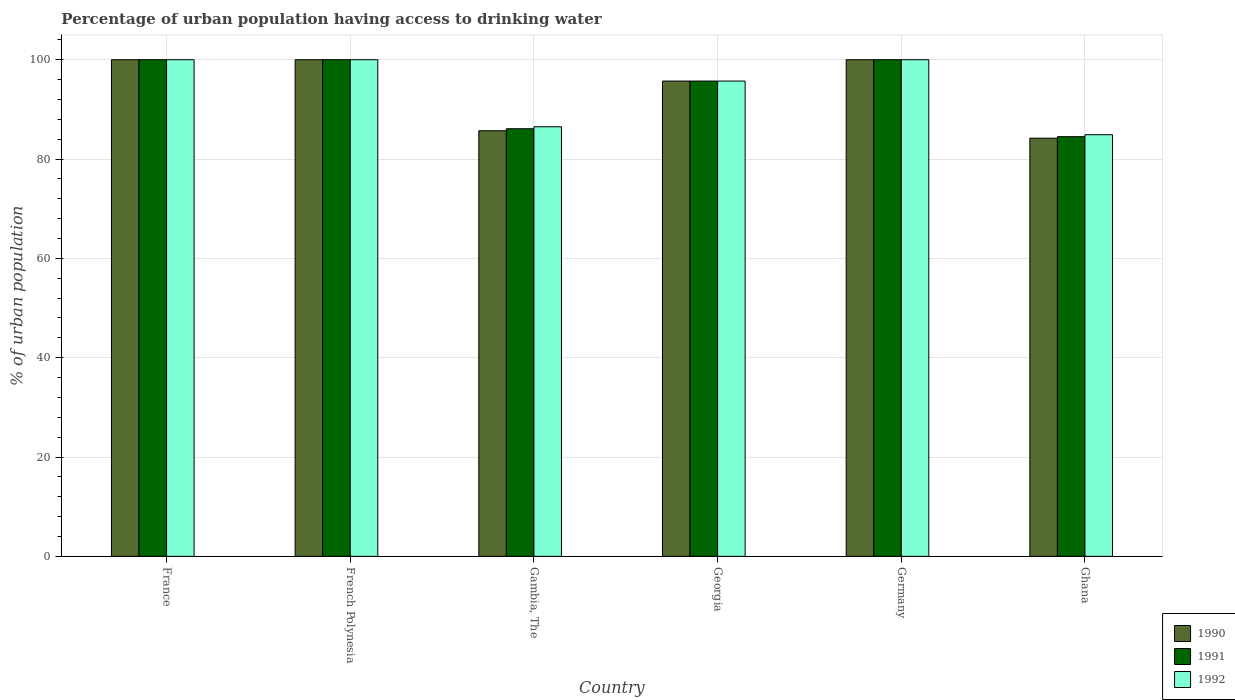How many different coloured bars are there?
Your answer should be compact. 3. How many groups of bars are there?
Give a very brief answer. 6. How many bars are there on the 5th tick from the right?
Offer a terse response. 3. What is the label of the 4th group of bars from the left?
Give a very brief answer. Georgia. What is the percentage of urban population having access to drinking water in 1991 in Ghana?
Offer a terse response. 84.5. Across all countries, what is the minimum percentage of urban population having access to drinking water in 1990?
Give a very brief answer. 84.2. In which country was the percentage of urban population having access to drinking water in 1990 maximum?
Provide a short and direct response. France. In which country was the percentage of urban population having access to drinking water in 1992 minimum?
Offer a very short reply. Ghana. What is the total percentage of urban population having access to drinking water in 1990 in the graph?
Give a very brief answer. 565.6. What is the difference between the percentage of urban population having access to drinking water in 1991 in France and that in Gambia, The?
Ensure brevity in your answer.  13.9. What is the difference between the percentage of urban population having access to drinking water in 1990 in Germany and the percentage of urban population having access to drinking water in 1992 in France?
Make the answer very short. 0. What is the average percentage of urban population having access to drinking water in 1991 per country?
Your answer should be compact. 94.38. What is the difference between the percentage of urban population having access to drinking water of/in 1990 and percentage of urban population having access to drinking water of/in 1992 in France?
Your response must be concise. 0. In how many countries, is the percentage of urban population having access to drinking water in 1991 greater than 68 %?
Your answer should be compact. 6. What is the ratio of the percentage of urban population having access to drinking water in 1991 in Georgia to that in Ghana?
Offer a terse response. 1.13. Is the difference between the percentage of urban population having access to drinking water in 1990 in France and French Polynesia greater than the difference between the percentage of urban population having access to drinking water in 1992 in France and French Polynesia?
Your response must be concise. No. What is the difference between the highest and the lowest percentage of urban population having access to drinking water in 1990?
Provide a short and direct response. 15.8. Is the sum of the percentage of urban population having access to drinking water in 1991 in France and Germany greater than the maximum percentage of urban population having access to drinking water in 1990 across all countries?
Provide a succinct answer. Yes. What does the 3rd bar from the right in Germany represents?
Offer a terse response. 1990. Is it the case that in every country, the sum of the percentage of urban population having access to drinking water in 1992 and percentage of urban population having access to drinking water in 1990 is greater than the percentage of urban population having access to drinking water in 1991?
Give a very brief answer. Yes. How many bars are there?
Provide a short and direct response. 18. Are all the bars in the graph horizontal?
Offer a very short reply. No. How many countries are there in the graph?
Offer a very short reply. 6. Are the values on the major ticks of Y-axis written in scientific E-notation?
Offer a terse response. No. How many legend labels are there?
Keep it short and to the point. 3. How are the legend labels stacked?
Offer a terse response. Vertical. What is the title of the graph?
Offer a terse response. Percentage of urban population having access to drinking water. Does "2002" appear as one of the legend labels in the graph?
Provide a short and direct response. No. What is the label or title of the Y-axis?
Give a very brief answer. % of urban population. What is the % of urban population of 1990 in France?
Provide a succinct answer. 100. What is the % of urban population of 1992 in France?
Offer a terse response. 100. What is the % of urban population in 1990 in Gambia, The?
Provide a short and direct response. 85.7. What is the % of urban population in 1991 in Gambia, The?
Offer a very short reply. 86.1. What is the % of urban population in 1992 in Gambia, The?
Give a very brief answer. 86.5. What is the % of urban population of 1990 in Georgia?
Your response must be concise. 95.7. What is the % of urban population in 1991 in Georgia?
Keep it short and to the point. 95.7. What is the % of urban population of 1992 in Georgia?
Make the answer very short. 95.7. What is the % of urban population in 1991 in Germany?
Ensure brevity in your answer.  100. What is the % of urban population in 1990 in Ghana?
Your response must be concise. 84.2. What is the % of urban population of 1991 in Ghana?
Provide a short and direct response. 84.5. What is the % of urban population of 1992 in Ghana?
Offer a terse response. 84.9. Across all countries, what is the maximum % of urban population in 1990?
Provide a succinct answer. 100. Across all countries, what is the minimum % of urban population of 1990?
Your response must be concise. 84.2. Across all countries, what is the minimum % of urban population in 1991?
Make the answer very short. 84.5. Across all countries, what is the minimum % of urban population of 1992?
Your answer should be compact. 84.9. What is the total % of urban population in 1990 in the graph?
Make the answer very short. 565.6. What is the total % of urban population of 1991 in the graph?
Give a very brief answer. 566.3. What is the total % of urban population of 1992 in the graph?
Make the answer very short. 567.1. What is the difference between the % of urban population in 1991 in France and that in French Polynesia?
Ensure brevity in your answer.  0. What is the difference between the % of urban population in 1992 in France and that in French Polynesia?
Ensure brevity in your answer.  0. What is the difference between the % of urban population of 1990 in France and that in Gambia, The?
Offer a very short reply. 14.3. What is the difference between the % of urban population in 1991 in France and that in Gambia, The?
Offer a very short reply. 13.9. What is the difference between the % of urban population in 1991 in France and that in Georgia?
Your answer should be compact. 4.3. What is the difference between the % of urban population in 1990 in France and that in Ghana?
Your response must be concise. 15.8. What is the difference between the % of urban population of 1991 in France and that in Ghana?
Make the answer very short. 15.5. What is the difference between the % of urban population in 1992 in France and that in Ghana?
Ensure brevity in your answer.  15.1. What is the difference between the % of urban population of 1990 in French Polynesia and that in Gambia, The?
Your answer should be compact. 14.3. What is the difference between the % of urban population in 1992 in French Polynesia and that in Georgia?
Give a very brief answer. 4.3. What is the difference between the % of urban population of 1990 in French Polynesia and that in Germany?
Your answer should be compact. 0. What is the difference between the % of urban population in 1991 in French Polynesia and that in Germany?
Your answer should be compact. 0. What is the difference between the % of urban population of 1992 in French Polynesia and that in Germany?
Your response must be concise. 0. What is the difference between the % of urban population in 1991 in French Polynesia and that in Ghana?
Offer a terse response. 15.5. What is the difference between the % of urban population of 1990 in Gambia, The and that in Georgia?
Make the answer very short. -10. What is the difference between the % of urban population in 1990 in Gambia, The and that in Germany?
Offer a terse response. -14.3. What is the difference between the % of urban population of 1992 in Gambia, The and that in Germany?
Make the answer very short. -13.5. What is the difference between the % of urban population in 1991 in Gambia, The and that in Ghana?
Ensure brevity in your answer.  1.6. What is the difference between the % of urban population of 1992 in Gambia, The and that in Ghana?
Your answer should be compact. 1.6. What is the difference between the % of urban population in 1991 in Georgia and that in Germany?
Offer a very short reply. -4.3. What is the difference between the % of urban population in 1990 in Georgia and that in Ghana?
Your answer should be very brief. 11.5. What is the difference between the % of urban population of 1990 in Germany and that in Ghana?
Provide a succinct answer. 15.8. What is the difference between the % of urban population of 1990 in France and the % of urban population of 1992 in French Polynesia?
Ensure brevity in your answer.  0. What is the difference between the % of urban population of 1991 in France and the % of urban population of 1992 in French Polynesia?
Offer a very short reply. 0. What is the difference between the % of urban population of 1990 in France and the % of urban population of 1991 in Gambia, The?
Offer a very short reply. 13.9. What is the difference between the % of urban population of 1990 in France and the % of urban population of 1992 in Gambia, The?
Your answer should be very brief. 13.5. What is the difference between the % of urban population of 1991 in France and the % of urban population of 1992 in Gambia, The?
Provide a short and direct response. 13.5. What is the difference between the % of urban population in 1990 in France and the % of urban population in 1992 in Georgia?
Make the answer very short. 4.3. What is the difference between the % of urban population in 1991 in France and the % of urban population in 1992 in Georgia?
Provide a succinct answer. 4.3. What is the difference between the % of urban population of 1990 in France and the % of urban population of 1992 in Ghana?
Provide a succinct answer. 15.1. What is the difference between the % of urban population of 1990 in French Polynesia and the % of urban population of 1991 in Gambia, The?
Make the answer very short. 13.9. What is the difference between the % of urban population of 1990 in French Polynesia and the % of urban population of 1992 in Georgia?
Ensure brevity in your answer.  4.3. What is the difference between the % of urban population in 1990 in French Polynesia and the % of urban population in 1991 in Germany?
Offer a very short reply. 0. What is the difference between the % of urban population of 1991 in French Polynesia and the % of urban population of 1992 in Germany?
Provide a short and direct response. 0. What is the difference between the % of urban population of 1990 in French Polynesia and the % of urban population of 1991 in Ghana?
Keep it short and to the point. 15.5. What is the difference between the % of urban population in 1990 in French Polynesia and the % of urban population in 1992 in Ghana?
Your answer should be very brief. 15.1. What is the difference between the % of urban population in 1990 in Gambia, The and the % of urban population in 1991 in Georgia?
Your answer should be compact. -10. What is the difference between the % of urban population in 1990 in Gambia, The and the % of urban population in 1992 in Georgia?
Your response must be concise. -10. What is the difference between the % of urban population of 1991 in Gambia, The and the % of urban population of 1992 in Georgia?
Your response must be concise. -9.6. What is the difference between the % of urban population in 1990 in Gambia, The and the % of urban population in 1991 in Germany?
Make the answer very short. -14.3. What is the difference between the % of urban population of 1990 in Gambia, The and the % of urban population of 1992 in Germany?
Offer a terse response. -14.3. What is the difference between the % of urban population in 1991 in Gambia, The and the % of urban population in 1992 in Ghana?
Provide a short and direct response. 1.2. What is the difference between the % of urban population of 1991 in Georgia and the % of urban population of 1992 in Germany?
Your answer should be compact. -4.3. What is the difference between the % of urban population of 1991 in Georgia and the % of urban population of 1992 in Ghana?
Ensure brevity in your answer.  10.8. What is the difference between the % of urban population of 1990 in Germany and the % of urban population of 1992 in Ghana?
Ensure brevity in your answer.  15.1. What is the difference between the % of urban population in 1991 in Germany and the % of urban population in 1992 in Ghana?
Make the answer very short. 15.1. What is the average % of urban population of 1990 per country?
Keep it short and to the point. 94.27. What is the average % of urban population in 1991 per country?
Provide a short and direct response. 94.38. What is the average % of urban population in 1992 per country?
Offer a terse response. 94.52. What is the difference between the % of urban population in 1990 and % of urban population in 1991 in France?
Your answer should be compact. 0. What is the difference between the % of urban population of 1990 and % of urban population of 1992 in French Polynesia?
Your response must be concise. 0. What is the difference between the % of urban population in 1990 and % of urban population in 1991 in Gambia, The?
Your response must be concise. -0.4. What is the difference between the % of urban population of 1990 and % of urban population of 1992 in Gambia, The?
Offer a very short reply. -0.8. What is the difference between the % of urban population of 1991 and % of urban population of 1992 in Gambia, The?
Provide a succinct answer. -0.4. What is the difference between the % of urban population in 1990 and % of urban population in 1992 in Germany?
Your answer should be compact. 0. What is the difference between the % of urban population in 1990 and % of urban population in 1991 in Ghana?
Your answer should be very brief. -0.3. What is the difference between the % of urban population of 1991 and % of urban population of 1992 in Ghana?
Offer a terse response. -0.4. What is the ratio of the % of urban population of 1990 in France to that in Gambia, The?
Give a very brief answer. 1.17. What is the ratio of the % of urban population of 1991 in France to that in Gambia, The?
Provide a succinct answer. 1.16. What is the ratio of the % of urban population in 1992 in France to that in Gambia, The?
Give a very brief answer. 1.16. What is the ratio of the % of urban population in 1990 in France to that in Georgia?
Provide a short and direct response. 1.04. What is the ratio of the % of urban population in 1991 in France to that in Georgia?
Keep it short and to the point. 1.04. What is the ratio of the % of urban population of 1992 in France to that in Georgia?
Provide a short and direct response. 1.04. What is the ratio of the % of urban population in 1990 in France to that in Ghana?
Offer a very short reply. 1.19. What is the ratio of the % of urban population in 1991 in France to that in Ghana?
Offer a terse response. 1.18. What is the ratio of the % of urban population of 1992 in France to that in Ghana?
Provide a short and direct response. 1.18. What is the ratio of the % of urban population in 1990 in French Polynesia to that in Gambia, The?
Ensure brevity in your answer.  1.17. What is the ratio of the % of urban population of 1991 in French Polynesia to that in Gambia, The?
Ensure brevity in your answer.  1.16. What is the ratio of the % of urban population of 1992 in French Polynesia to that in Gambia, The?
Offer a very short reply. 1.16. What is the ratio of the % of urban population in 1990 in French Polynesia to that in Georgia?
Your answer should be compact. 1.04. What is the ratio of the % of urban population in 1991 in French Polynesia to that in Georgia?
Offer a terse response. 1.04. What is the ratio of the % of urban population of 1992 in French Polynesia to that in Georgia?
Provide a short and direct response. 1.04. What is the ratio of the % of urban population in 1990 in French Polynesia to that in Germany?
Make the answer very short. 1. What is the ratio of the % of urban population of 1991 in French Polynesia to that in Germany?
Give a very brief answer. 1. What is the ratio of the % of urban population of 1992 in French Polynesia to that in Germany?
Provide a short and direct response. 1. What is the ratio of the % of urban population of 1990 in French Polynesia to that in Ghana?
Provide a short and direct response. 1.19. What is the ratio of the % of urban population of 1991 in French Polynesia to that in Ghana?
Provide a succinct answer. 1.18. What is the ratio of the % of urban population of 1992 in French Polynesia to that in Ghana?
Ensure brevity in your answer.  1.18. What is the ratio of the % of urban population of 1990 in Gambia, The to that in Georgia?
Provide a short and direct response. 0.9. What is the ratio of the % of urban population of 1991 in Gambia, The to that in Georgia?
Offer a terse response. 0.9. What is the ratio of the % of urban population in 1992 in Gambia, The to that in Georgia?
Offer a very short reply. 0.9. What is the ratio of the % of urban population of 1990 in Gambia, The to that in Germany?
Provide a succinct answer. 0.86. What is the ratio of the % of urban population of 1991 in Gambia, The to that in Germany?
Provide a short and direct response. 0.86. What is the ratio of the % of urban population of 1992 in Gambia, The to that in Germany?
Ensure brevity in your answer.  0.86. What is the ratio of the % of urban population of 1990 in Gambia, The to that in Ghana?
Offer a very short reply. 1.02. What is the ratio of the % of urban population of 1991 in Gambia, The to that in Ghana?
Your answer should be compact. 1.02. What is the ratio of the % of urban population in 1992 in Gambia, The to that in Ghana?
Ensure brevity in your answer.  1.02. What is the ratio of the % of urban population in 1992 in Georgia to that in Germany?
Ensure brevity in your answer.  0.96. What is the ratio of the % of urban population in 1990 in Georgia to that in Ghana?
Give a very brief answer. 1.14. What is the ratio of the % of urban population in 1991 in Georgia to that in Ghana?
Your answer should be compact. 1.13. What is the ratio of the % of urban population in 1992 in Georgia to that in Ghana?
Give a very brief answer. 1.13. What is the ratio of the % of urban population of 1990 in Germany to that in Ghana?
Your answer should be compact. 1.19. What is the ratio of the % of urban population in 1991 in Germany to that in Ghana?
Make the answer very short. 1.18. What is the ratio of the % of urban population in 1992 in Germany to that in Ghana?
Your response must be concise. 1.18. What is the difference between the highest and the second highest % of urban population in 1992?
Your answer should be very brief. 0. What is the difference between the highest and the lowest % of urban population in 1990?
Your answer should be very brief. 15.8. What is the difference between the highest and the lowest % of urban population in 1992?
Keep it short and to the point. 15.1. 